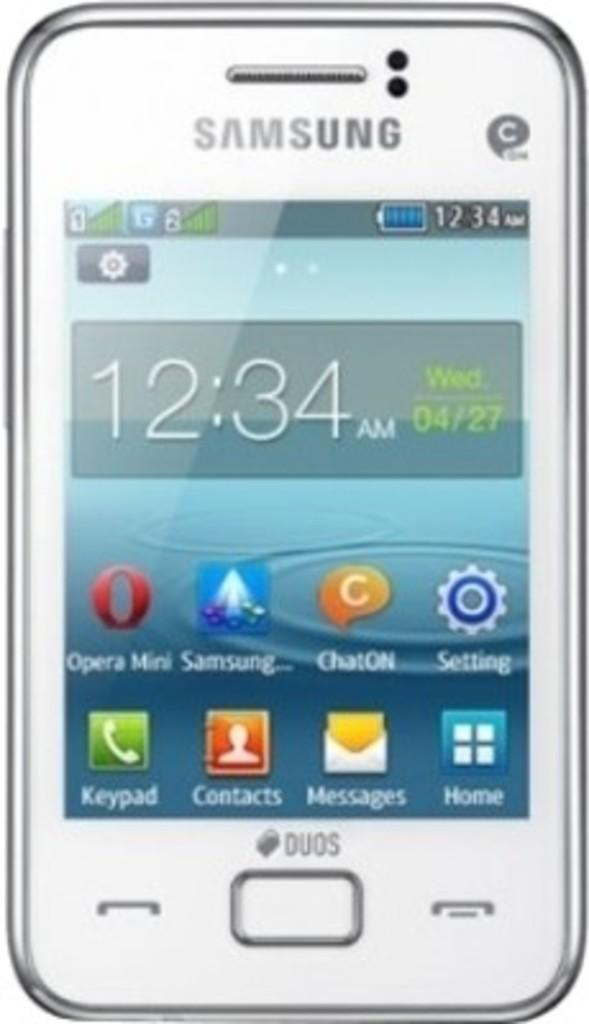<image>
Offer a succinct explanation of the picture presented. A Samsung phone is shown with the time 12:34 AM. 